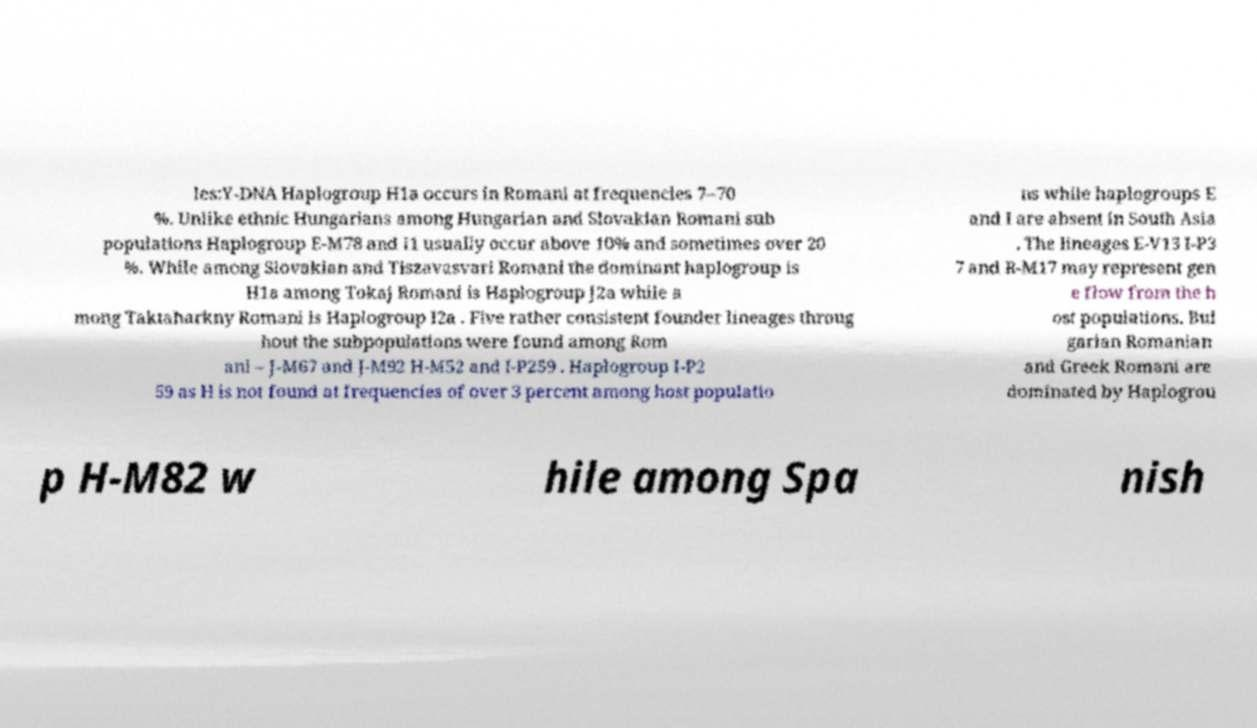What messages or text are displayed in this image? I need them in a readable, typed format. les:Y-DNA Haplogroup H1a occurs in Romani at frequencies 7–70 %. Unlike ethnic Hungarians among Hungarian and Slovakian Romani sub populations Haplogroup E-M78 and I1 usually occur above 10% and sometimes over 20 %. While among Slovakian and Tiszavasvari Romani the dominant haplogroup is H1a among Tokaj Romani is Haplogroup J2a while a mong Taktaharkny Romani is Haplogroup I2a . Five rather consistent founder lineages throug hout the subpopulations were found among Rom ani – J-M67 and J-M92 H-M52 and I-P259 . Haplogroup I-P2 59 as H is not found at frequencies of over 3 percent among host populatio ns while haplogroups E and I are absent in South Asia . The lineages E-V13 I-P3 7 and R-M17 may represent gen e flow from the h ost populations. Bul garian Romanian and Greek Romani are dominated by Haplogrou p H-M82 w hile among Spa nish 